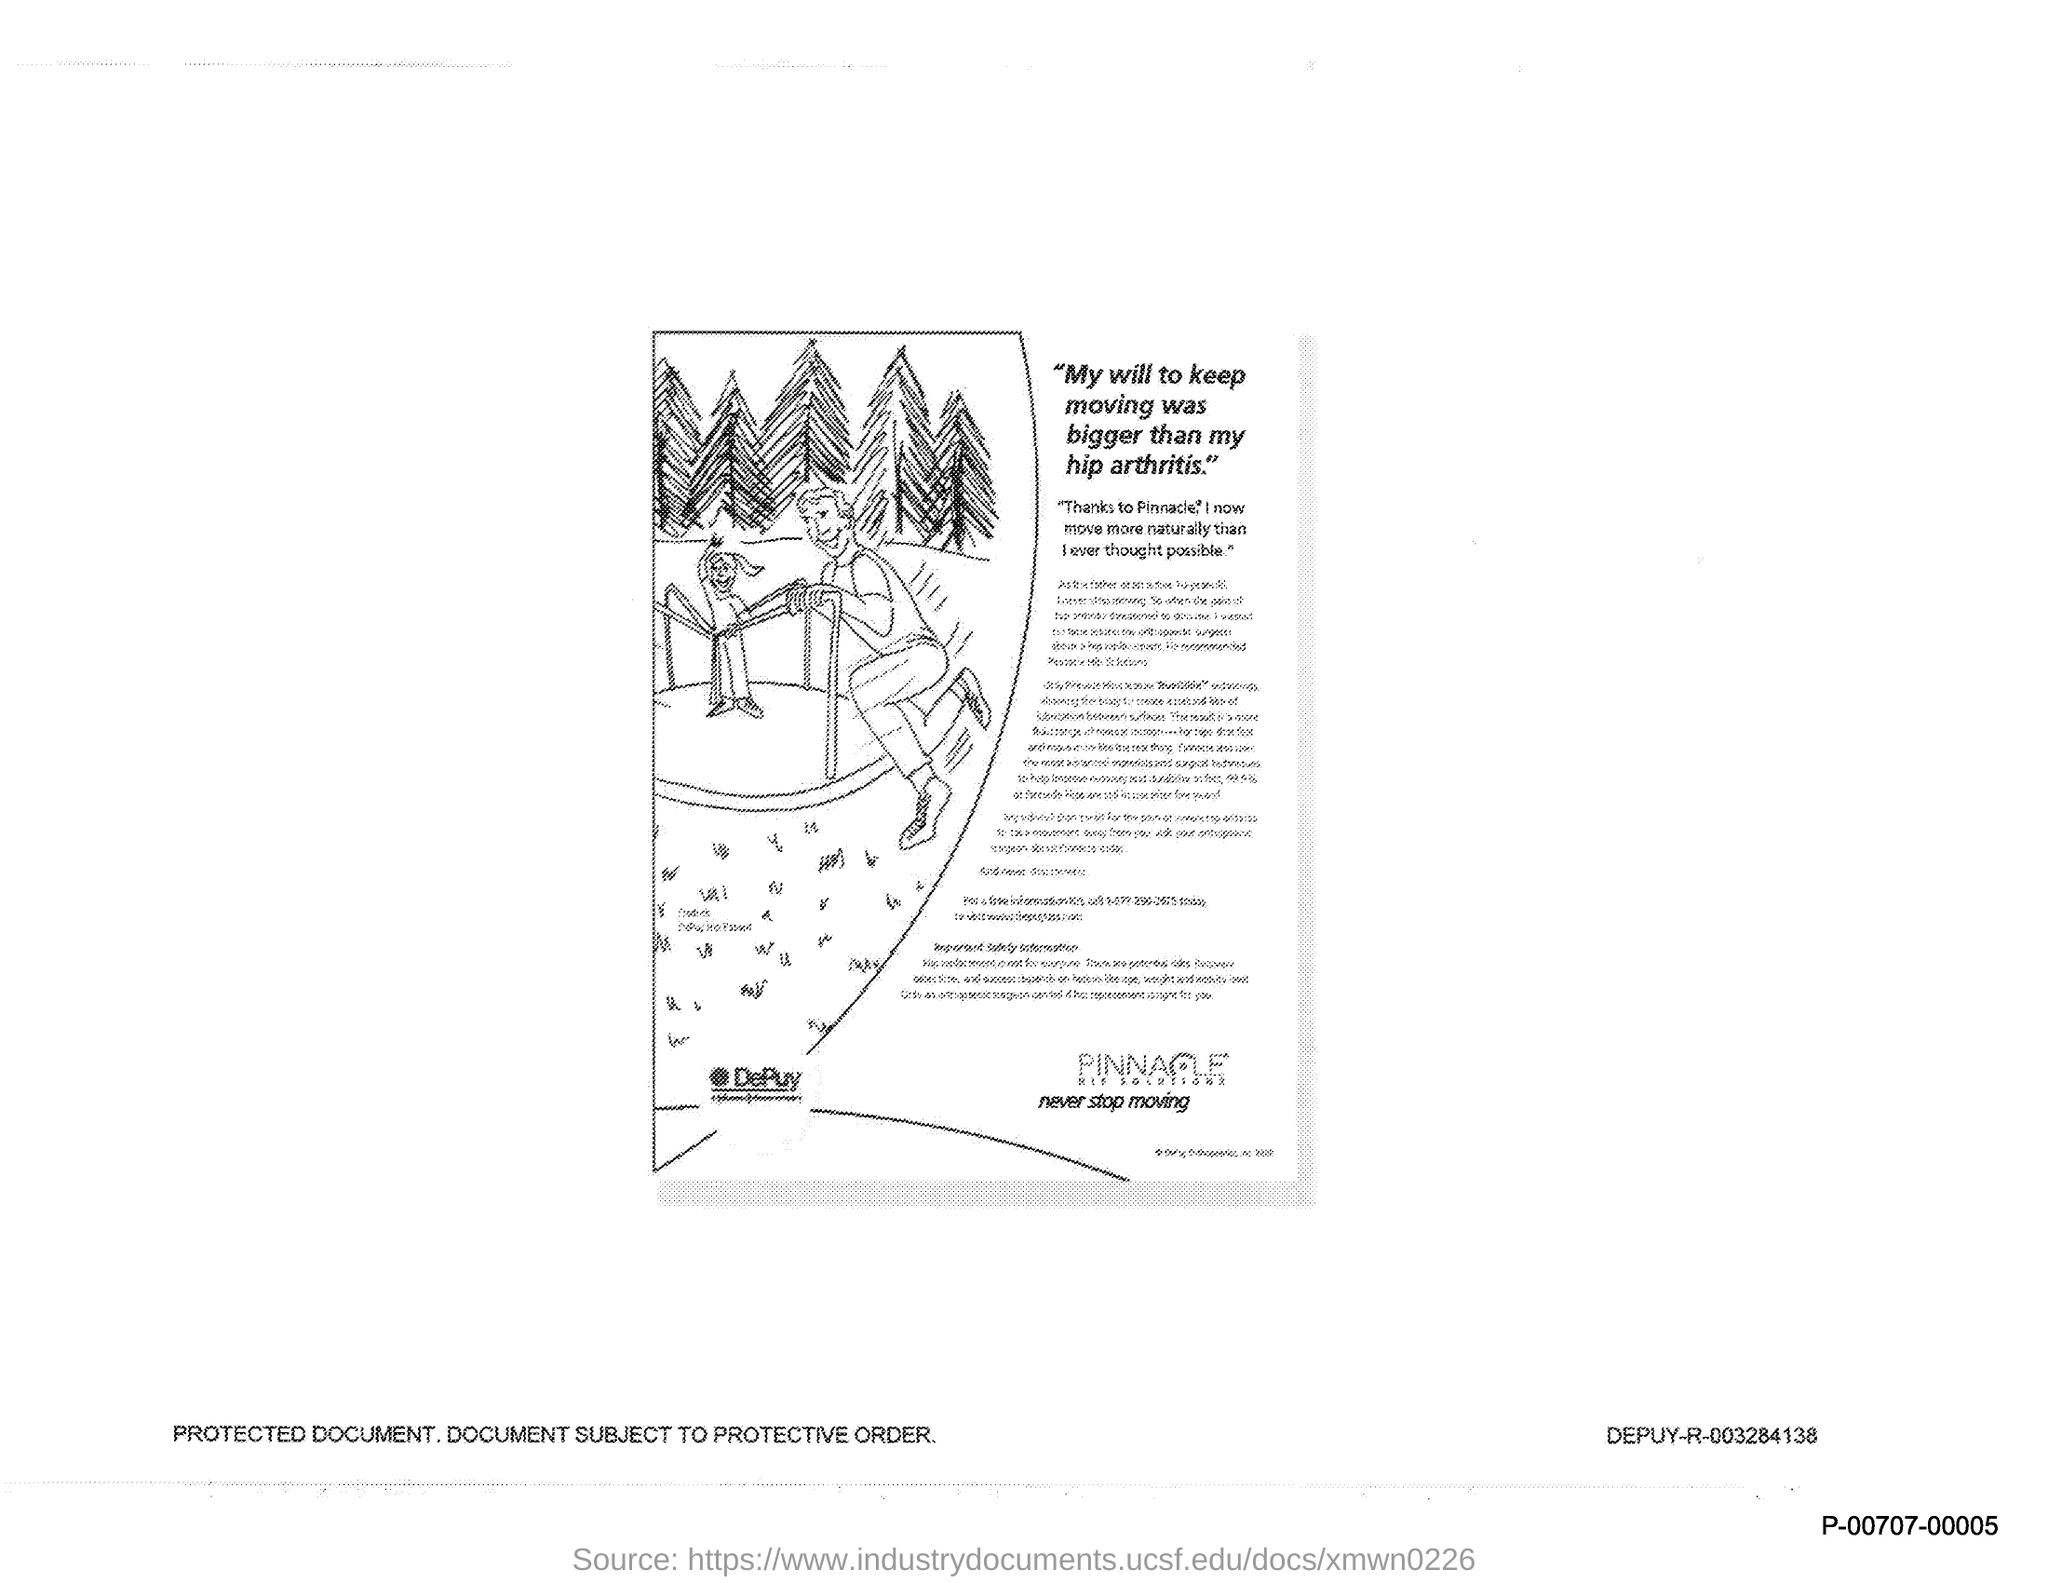Indicate a few pertinent items in this graphic. My will to keep moving was stronger than my hip arthritis, as evidenced by the fact that I was the first title in the document. 